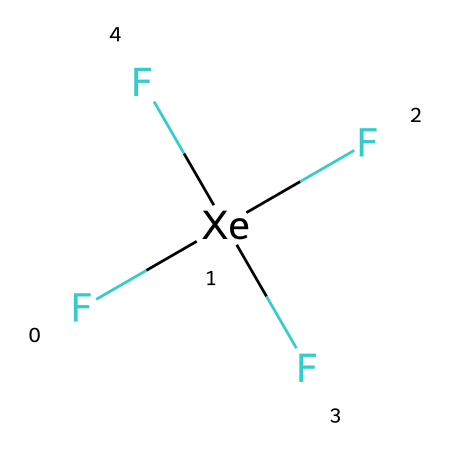What is the total number of fluorine atoms in xenon tetrafluoride? The SMILES representation shows four fluorine (F) atoms surrounding the xenon (Xe) atom. This indicates that there are four fluorine atoms in total.
Answer: four How many bonds are present around the xenon atom? Each fluorine atom is bonded to the central xenon atom. Since there are four fluorine atoms, there are four bonds formed around the xenon atom.
Answer: four Is xenon tetrafluoride a hypervalent compound? Xenon tetrafluoride has more than eight electrons around the xenon atom (it has 12 electrons due to the four F-Xe bonds), which qualifies it as a hypervalent compound.
Answer: yes What geometric shape is expected for xenon tetrafluoride? With four fluorine atoms symmetrically arranged around the xenon atom, the molecular geometry is tetrahedral.
Answer: tetrahedral What type of compound is xenon tetrafluoride? Being formed from a noble gas (xenon) and halogen (fluorine), xenon tetrafluoride is classified as a noble gas compound.
Answer: noble gas compound How does the presence of fluorine affect the reactivity of xenon? Fluorine is a highly electronegative element, which enhances the reactivity of xenon in xenon tetrafluoride compared to its elemental state.
Answer: increases reactivity What is the oxidation state of xenon in xenon tetrafluoride? In xenon tetrafluoride, xenon has an oxidation state of +4, which can be deduced from the four -1 oxidation states of the fluorine atoms.
Answer: +4 